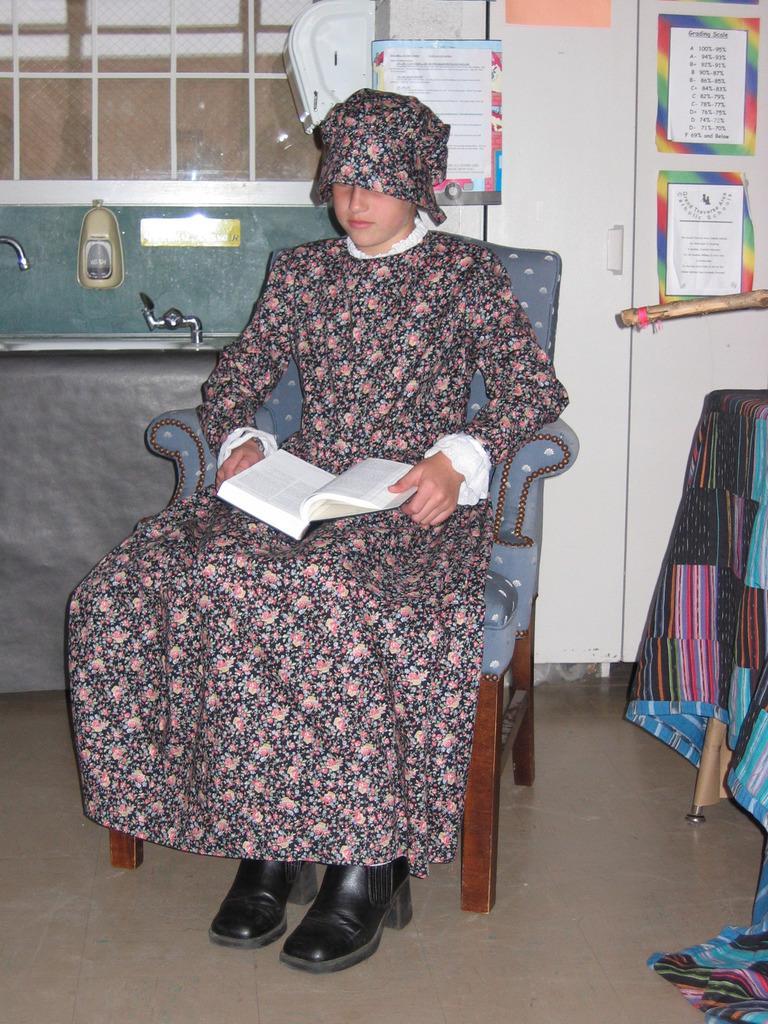Can you describe this image briefly? In this image I see a girl who is sitting on chair and she is holding a book, In the background I see few papers. 